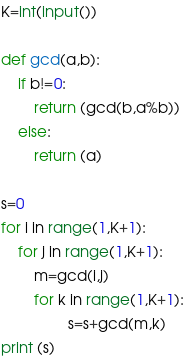Convert code to text. <code><loc_0><loc_0><loc_500><loc_500><_Python_>K=int(input())

def gcd(a,b):
    if b!=0:
        return (gcd(b,a%b))
    else:
        return (a)

s=0
for i in range(1,K+1):
    for j in range(1,K+1):
        m=gcd(i,j)
        for k in range(1,K+1):
                s=s+gcd(m,k)
print (s)</code> 